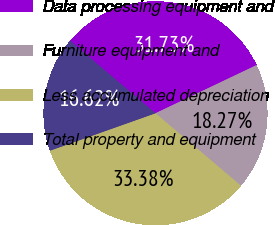<chart> <loc_0><loc_0><loc_500><loc_500><pie_chart><fcel>Data processing equipment and<fcel>Furniture equipment and<fcel>Less accumulated depreciation<fcel>Total property and equipment<nl><fcel>31.73%<fcel>18.27%<fcel>33.38%<fcel>16.62%<nl></chart> 